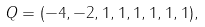Convert formula to latex. <formula><loc_0><loc_0><loc_500><loc_500>Q = ( - 4 , - 2 , 1 , 1 , 1 , 1 , 1 , 1 ) ,</formula> 